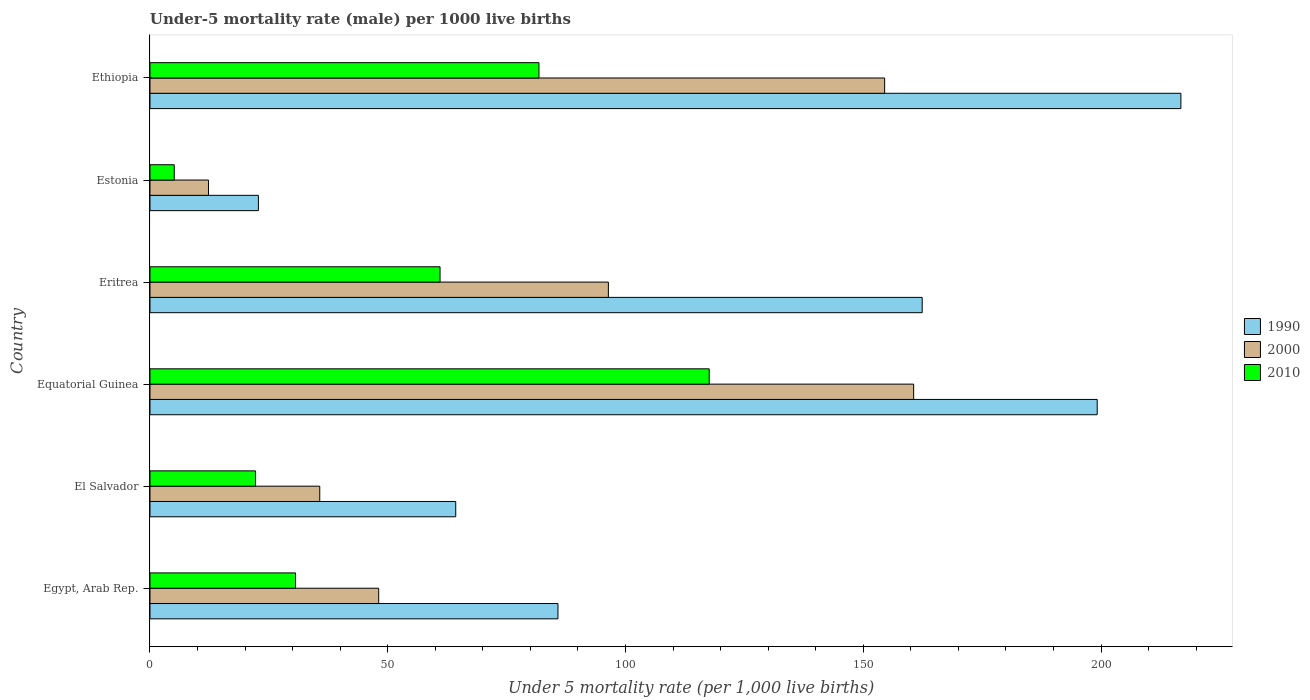How many different coloured bars are there?
Offer a terse response. 3. Are the number of bars per tick equal to the number of legend labels?
Provide a short and direct response. Yes. How many bars are there on the 6th tick from the bottom?
Offer a terse response. 3. What is the label of the 1st group of bars from the top?
Provide a succinct answer. Ethiopia. In how many cases, is the number of bars for a given country not equal to the number of legend labels?
Give a very brief answer. 0. What is the under-five mortality rate in 2000 in Eritrea?
Make the answer very short. 96.4. Across all countries, what is the maximum under-five mortality rate in 2000?
Your answer should be very brief. 160.6. Across all countries, what is the minimum under-five mortality rate in 2010?
Your response must be concise. 5.1. In which country was the under-five mortality rate in 2000 maximum?
Offer a terse response. Equatorial Guinea. In which country was the under-five mortality rate in 1990 minimum?
Ensure brevity in your answer.  Estonia. What is the total under-five mortality rate in 1990 in the graph?
Offer a terse response. 751.3. What is the difference between the under-five mortality rate in 2010 in Eritrea and that in Estonia?
Make the answer very short. 55.9. What is the difference between the under-five mortality rate in 1990 in Estonia and the under-five mortality rate in 2000 in Egypt, Arab Rep.?
Provide a short and direct response. -25.3. What is the average under-five mortality rate in 2010 per country?
Give a very brief answer. 53.05. What is the difference between the under-five mortality rate in 1990 and under-five mortality rate in 2010 in Estonia?
Provide a short and direct response. 17.7. What is the ratio of the under-five mortality rate in 1990 in Eritrea to that in Estonia?
Provide a short and direct response. 7.12. Is the under-five mortality rate in 2010 in El Salvador less than that in Ethiopia?
Offer a terse response. Yes. Is the difference between the under-five mortality rate in 1990 in Egypt, Arab Rep. and Estonia greater than the difference between the under-five mortality rate in 2010 in Egypt, Arab Rep. and Estonia?
Keep it short and to the point. Yes. What is the difference between the highest and the second highest under-five mortality rate in 2000?
Offer a very short reply. 6.1. What is the difference between the highest and the lowest under-five mortality rate in 2010?
Your response must be concise. 112.5. In how many countries, is the under-five mortality rate in 2010 greater than the average under-five mortality rate in 2010 taken over all countries?
Offer a very short reply. 3. Is the sum of the under-five mortality rate in 2010 in Eritrea and Estonia greater than the maximum under-five mortality rate in 1990 across all countries?
Provide a short and direct response. No. What does the 2nd bar from the top in Ethiopia represents?
Provide a succinct answer. 2000. Is it the case that in every country, the sum of the under-five mortality rate in 2000 and under-five mortality rate in 1990 is greater than the under-five mortality rate in 2010?
Keep it short and to the point. Yes. How many bars are there?
Ensure brevity in your answer.  18. What is the difference between two consecutive major ticks on the X-axis?
Your answer should be very brief. 50. Does the graph contain any zero values?
Provide a succinct answer. No. Where does the legend appear in the graph?
Give a very brief answer. Center right. How many legend labels are there?
Provide a short and direct response. 3. What is the title of the graph?
Keep it short and to the point. Under-5 mortality rate (male) per 1000 live births. What is the label or title of the X-axis?
Ensure brevity in your answer.  Under 5 mortality rate (per 1,0 live births). What is the label or title of the Y-axis?
Your answer should be very brief. Country. What is the Under 5 mortality rate (per 1,000 live births) of 1990 in Egypt, Arab Rep.?
Ensure brevity in your answer.  85.8. What is the Under 5 mortality rate (per 1,000 live births) of 2000 in Egypt, Arab Rep.?
Provide a succinct answer. 48.1. What is the Under 5 mortality rate (per 1,000 live births) of 2010 in Egypt, Arab Rep.?
Offer a very short reply. 30.6. What is the Under 5 mortality rate (per 1,000 live births) of 1990 in El Salvador?
Provide a short and direct response. 64.3. What is the Under 5 mortality rate (per 1,000 live births) of 2000 in El Salvador?
Provide a short and direct response. 35.7. What is the Under 5 mortality rate (per 1,000 live births) in 1990 in Equatorial Guinea?
Make the answer very short. 199.2. What is the Under 5 mortality rate (per 1,000 live births) of 2000 in Equatorial Guinea?
Provide a succinct answer. 160.6. What is the Under 5 mortality rate (per 1,000 live births) of 2010 in Equatorial Guinea?
Your answer should be very brief. 117.6. What is the Under 5 mortality rate (per 1,000 live births) of 1990 in Eritrea?
Your answer should be compact. 162.4. What is the Under 5 mortality rate (per 1,000 live births) in 2000 in Eritrea?
Provide a short and direct response. 96.4. What is the Under 5 mortality rate (per 1,000 live births) of 2010 in Eritrea?
Make the answer very short. 61. What is the Under 5 mortality rate (per 1,000 live births) in 1990 in Estonia?
Keep it short and to the point. 22.8. What is the Under 5 mortality rate (per 1,000 live births) of 1990 in Ethiopia?
Your answer should be very brief. 216.8. What is the Under 5 mortality rate (per 1,000 live births) in 2000 in Ethiopia?
Ensure brevity in your answer.  154.5. What is the Under 5 mortality rate (per 1,000 live births) in 2010 in Ethiopia?
Ensure brevity in your answer.  81.8. Across all countries, what is the maximum Under 5 mortality rate (per 1,000 live births) of 1990?
Offer a terse response. 216.8. Across all countries, what is the maximum Under 5 mortality rate (per 1,000 live births) of 2000?
Your answer should be compact. 160.6. Across all countries, what is the maximum Under 5 mortality rate (per 1,000 live births) in 2010?
Ensure brevity in your answer.  117.6. Across all countries, what is the minimum Under 5 mortality rate (per 1,000 live births) in 1990?
Offer a terse response. 22.8. What is the total Under 5 mortality rate (per 1,000 live births) of 1990 in the graph?
Ensure brevity in your answer.  751.3. What is the total Under 5 mortality rate (per 1,000 live births) in 2000 in the graph?
Offer a terse response. 507.6. What is the total Under 5 mortality rate (per 1,000 live births) of 2010 in the graph?
Your answer should be very brief. 318.3. What is the difference between the Under 5 mortality rate (per 1,000 live births) of 1990 in Egypt, Arab Rep. and that in El Salvador?
Ensure brevity in your answer.  21.5. What is the difference between the Under 5 mortality rate (per 1,000 live births) in 2000 in Egypt, Arab Rep. and that in El Salvador?
Provide a short and direct response. 12.4. What is the difference between the Under 5 mortality rate (per 1,000 live births) of 1990 in Egypt, Arab Rep. and that in Equatorial Guinea?
Provide a succinct answer. -113.4. What is the difference between the Under 5 mortality rate (per 1,000 live births) in 2000 in Egypt, Arab Rep. and that in Equatorial Guinea?
Give a very brief answer. -112.5. What is the difference between the Under 5 mortality rate (per 1,000 live births) of 2010 in Egypt, Arab Rep. and that in Equatorial Guinea?
Your answer should be very brief. -87. What is the difference between the Under 5 mortality rate (per 1,000 live births) of 1990 in Egypt, Arab Rep. and that in Eritrea?
Ensure brevity in your answer.  -76.6. What is the difference between the Under 5 mortality rate (per 1,000 live births) of 2000 in Egypt, Arab Rep. and that in Eritrea?
Give a very brief answer. -48.3. What is the difference between the Under 5 mortality rate (per 1,000 live births) of 2010 in Egypt, Arab Rep. and that in Eritrea?
Give a very brief answer. -30.4. What is the difference between the Under 5 mortality rate (per 1,000 live births) of 1990 in Egypt, Arab Rep. and that in Estonia?
Provide a short and direct response. 63. What is the difference between the Under 5 mortality rate (per 1,000 live births) in 2000 in Egypt, Arab Rep. and that in Estonia?
Ensure brevity in your answer.  35.8. What is the difference between the Under 5 mortality rate (per 1,000 live births) in 2010 in Egypt, Arab Rep. and that in Estonia?
Your response must be concise. 25.5. What is the difference between the Under 5 mortality rate (per 1,000 live births) of 1990 in Egypt, Arab Rep. and that in Ethiopia?
Your answer should be very brief. -131. What is the difference between the Under 5 mortality rate (per 1,000 live births) in 2000 in Egypt, Arab Rep. and that in Ethiopia?
Make the answer very short. -106.4. What is the difference between the Under 5 mortality rate (per 1,000 live births) of 2010 in Egypt, Arab Rep. and that in Ethiopia?
Keep it short and to the point. -51.2. What is the difference between the Under 5 mortality rate (per 1,000 live births) in 1990 in El Salvador and that in Equatorial Guinea?
Provide a succinct answer. -134.9. What is the difference between the Under 5 mortality rate (per 1,000 live births) in 2000 in El Salvador and that in Equatorial Guinea?
Provide a succinct answer. -124.9. What is the difference between the Under 5 mortality rate (per 1,000 live births) of 2010 in El Salvador and that in Equatorial Guinea?
Offer a very short reply. -95.4. What is the difference between the Under 5 mortality rate (per 1,000 live births) of 1990 in El Salvador and that in Eritrea?
Provide a short and direct response. -98.1. What is the difference between the Under 5 mortality rate (per 1,000 live births) of 2000 in El Salvador and that in Eritrea?
Your answer should be very brief. -60.7. What is the difference between the Under 5 mortality rate (per 1,000 live births) in 2010 in El Salvador and that in Eritrea?
Your answer should be compact. -38.8. What is the difference between the Under 5 mortality rate (per 1,000 live births) of 1990 in El Salvador and that in Estonia?
Offer a very short reply. 41.5. What is the difference between the Under 5 mortality rate (per 1,000 live births) of 2000 in El Salvador and that in Estonia?
Provide a succinct answer. 23.4. What is the difference between the Under 5 mortality rate (per 1,000 live births) in 2010 in El Salvador and that in Estonia?
Give a very brief answer. 17.1. What is the difference between the Under 5 mortality rate (per 1,000 live births) in 1990 in El Salvador and that in Ethiopia?
Offer a terse response. -152.5. What is the difference between the Under 5 mortality rate (per 1,000 live births) in 2000 in El Salvador and that in Ethiopia?
Offer a terse response. -118.8. What is the difference between the Under 5 mortality rate (per 1,000 live births) in 2010 in El Salvador and that in Ethiopia?
Make the answer very short. -59.6. What is the difference between the Under 5 mortality rate (per 1,000 live births) in 1990 in Equatorial Guinea and that in Eritrea?
Your answer should be compact. 36.8. What is the difference between the Under 5 mortality rate (per 1,000 live births) in 2000 in Equatorial Guinea and that in Eritrea?
Your answer should be very brief. 64.2. What is the difference between the Under 5 mortality rate (per 1,000 live births) in 2010 in Equatorial Guinea and that in Eritrea?
Your response must be concise. 56.6. What is the difference between the Under 5 mortality rate (per 1,000 live births) of 1990 in Equatorial Guinea and that in Estonia?
Offer a very short reply. 176.4. What is the difference between the Under 5 mortality rate (per 1,000 live births) of 2000 in Equatorial Guinea and that in Estonia?
Give a very brief answer. 148.3. What is the difference between the Under 5 mortality rate (per 1,000 live births) in 2010 in Equatorial Guinea and that in Estonia?
Your answer should be compact. 112.5. What is the difference between the Under 5 mortality rate (per 1,000 live births) in 1990 in Equatorial Guinea and that in Ethiopia?
Your response must be concise. -17.6. What is the difference between the Under 5 mortality rate (per 1,000 live births) in 2000 in Equatorial Guinea and that in Ethiopia?
Your response must be concise. 6.1. What is the difference between the Under 5 mortality rate (per 1,000 live births) in 2010 in Equatorial Guinea and that in Ethiopia?
Keep it short and to the point. 35.8. What is the difference between the Under 5 mortality rate (per 1,000 live births) in 1990 in Eritrea and that in Estonia?
Ensure brevity in your answer.  139.6. What is the difference between the Under 5 mortality rate (per 1,000 live births) of 2000 in Eritrea and that in Estonia?
Your answer should be compact. 84.1. What is the difference between the Under 5 mortality rate (per 1,000 live births) of 2010 in Eritrea and that in Estonia?
Provide a short and direct response. 55.9. What is the difference between the Under 5 mortality rate (per 1,000 live births) of 1990 in Eritrea and that in Ethiopia?
Your answer should be compact. -54.4. What is the difference between the Under 5 mortality rate (per 1,000 live births) of 2000 in Eritrea and that in Ethiopia?
Offer a terse response. -58.1. What is the difference between the Under 5 mortality rate (per 1,000 live births) of 2010 in Eritrea and that in Ethiopia?
Offer a very short reply. -20.8. What is the difference between the Under 5 mortality rate (per 1,000 live births) of 1990 in Estonia and that in Ethiopia?
Offer a very short reply. -194. What is the difference between the Under 5 mortality rate (per 1,000 live births) of 2000 in Estonia and that in Ethiopia?
Provide a short and direct response. -142.2. What is the difference between the Under 5 mortality rate (per 1,000 live births) of 2010 in Estonia and that in Ethiopia?
Ensure brevity in your answer.  -76.7. What is the difference between the Under 5 mortality rate (per 1,000 live births) of 1990 in Egypt, Arab Rep. and the Under 5 mortality rate (per 1,000 live births) of 2000 in El Salvador?
Provide a succinct answer. 50.1. What is the difference between the Under 5 mortality rate (per 1,000 live births) in 1990 in Egypt, Arab Rep. and the Under 5 mortality rate (per 1,000 live births) in 2010 in El Salvador?
Keep it short and to the point. 63.6. What is the difference between the Under 5 mortality rate (per 1,000 live births) of 2000 in Egypt, Arab Rep. and the Under 5 mortality rate (per 1,000 live births) of 2010 in El Salvador?
Provide a short and direct response. 25.9. What is the difference between the Under 5 mortality rate (per 1,000 live births) of 1990 in Egypt, Arab Rep. and the Under 5 mortality rate (per 1,000 live births) of 2000 in Equatorial Guinea?
Make the answer very short. -74.8. What is the difference between the Under 5 mortality rate (per 1,000 live births) of 1990 in Egypt, Arab Rep. and the Under 5 mortality rate (per 1,000 live births) of 2010 in Equatorial Guinea?
Your answer should be very brief. -31.8. What is the difference between the Under 5 mortality rate (per 1,000 live births) of 2000 in Egypt, Arab Rep. and the Under 5 mortality rate (per 1,000 live births) of 2010 in Equatorial Guinea?
Keep it short and to the point. -69.5. What is the difference between the Under 5 mortality rate (per 1,000 live births) in 1990 in Egypt, Arab Rep. and the Under 5 mortality rate (per 1,000 live births) in 2010 in Eritrea?
Your answer should be very brief. 24.8. What is the difference between the Under 5 mortality rate (per 1,000 live births) in 1990 in Egypt, Arab Rep. and the Under 5 mortality rate (per 1,000 live births) in 2000 in Estonia?
Provide a short and direct response. 73.5. What is the difference between the Under 5 mortality rate (per 1,000 live births) of 1990 in Egypt, Arab Rep. and the Under 5 mortality rate (per 1,000 live births) of 2010 in Estonia?
Give a very brief answer. 80.7. What is the difference between the Under 5 mortality rate (per 1,000 live births) in 1990 in Egypt, Arab Rep. and the Under 5 mortality rate (per 1,000 live births) in 2000 in Ethiopia?
Offer a very short reply. -68.7. What is the difference between the Under 5 mortality rate (per 1,000 live births) of 1990 in Egypt, Arab Rep. and the Under 5 mortality rate (per 1,000 live births) of 2010 in Ethiopia?
Offer a very short reply. 4. What is the difference between the Under 5 mortality rate (per 1,000 live births) of 2000 in Egypt, Arab Rep. and the Under 5 mortality rate (per 1,000 live births) of 2010 in Ethiopia?
Your answer should be compact. -33.7. What is the difference between the Under 5 mortality rate (per 1,000 live births) of 1990 in El Salvador and the Under 5 mortality rate (per 1,000 live births) of 2000 in Equatorial Guinea?
Make the answer very short. -96.3. What is the difference between the Under 5 mortality rate (per 1,000 live births) in 1990 in El Salvador and the Under 5 mortality rate (per 1,000 live births) in 2010 in Equatorial Guinea?
Make the answer very short. -53.3. What is the difference between the Under 5 mortality rate (per 1,000 live births) in 2000 in El Salvador and the Under 5 mortality rate (per 1,000 live births) in 2010 in Equatorial Guinea?
Provide a succinct answer. -81.9. What is the difference between the Under 5 mortality rate (per 1,000 live births) of 1990 in El Salvador and the Under 5 mortality rate (per 1,000 live births) of 2000 in Eritrea?
Your answer should be very brief. -32.1. What is the difference between the Under 5 mortality rate (per 1,000 live births) in 1990 in El Salvador and the Under 5 mortality rate (per 1,000 live births) in 2010 in Eritrea?
Offer a very short reply. 3.3. What is the difference between the Under 5 mortality rate (per 1,000 live births) in 2000 in El Salvador and the Under 5 mortality rate (per 1,000 live births) in 2010 in Eritrea?
Your response must be concise. -25.3. What is the difference between the Under 5 mortality rate (per 1,000 live births) of 1990 in El Salvador and the Under 5 mortality rate (per 1,000 live births) of 2010 in Estonia?
Provide a short and direct response. 59.2. What is the difference between the Under 5 mortality rate (per 1,000 live births) in 2000 in El Salvador and the Under 5 mortality rate (per 1,000 live births) in 2010 in Estonia?
Provide a succinct answer. 30.6. What is the difference between the Under 5 mortality rate (per 1,000 live births) of 1990 in El Salvador and the Under 5 mortality rate (per 1,000 live births) of 2000 in Ethiopia?
Keep it short and to the point. -90.2. What is the difference between the Under 5 mortality rate (per 1,000 live births) of 1990 in El Salvador and the Under 5 mortality rate (per 1,000 live births) of 2010 in Ethiopia?
Make the answer very short. -17.5. What is the difference between the Under 5 mortality rate (per 1,000 live births) in 2000 in El Salvador and the Under 5 mortality rate (per 1,000 live births) in 2010 in Ethiopia?
Your response must be concise. -46.1. What is the difference between the Under 5 mortality rate (per 1,000 live births) in 1990 in Equatorial Guinea and the Under 5 mortality rate (per 1,000 live births) in 2000 in Eritrea?
Give a very brief answer. 102.8. What is the difference between the Under 5 mortality rate (per 1,000 live births) of 1990 in Equatorial Guinea and the Under 5 mortality rate (per 1,000 live births) of 2010 in Eritrea?
Your response must be concise. 138.2. What is the difference between the Under 5 mortality rate (per 1,000 live births) in 2000 in Equatorial Guinea and the Under 5 mortality rate (per 1,000 live births) in 2010 in Eritrea?
Provide a succinct answer. 99.6. What is the difference between the Under 5 mortality rate (per 1,000 live births) of 1990 in Equatorial Guinea and the Under 5 mortality rate (per 1,000 live births) of 2000 in Estonia?
Ensure brevity in your answer.  186.9. What is the difference between the Under 5 mortality rate (per 1,000 live births) in 1990 in Equatorial Guinea and the Under 5 mortality rate (per 1,000 live births) in 2010 in Estonia?
Provide a succinct answer. 194.1. What is the difference between the Under 5 mortality rate (per 1,000 live births) of 2000 in Equatorial Guinea and the Under 5 mortality rate (per 1,000 live births) of 2010 in Estonia?
Give a very brief answer. 155.5. What is the difference between the Under 5 mortality rate (per 1,000 live births) of 1990 in Equatorial Guinea and the Under 5 mortality rate (per 1,000 live births) of 2000 in Ethiopia?
Offer a very short reply. 44.7. What is the difference between the Under 5 mortality rate (per 1,000 live births) of 1990 in Equatorial Guinea and the Under 5 mortality rate (per 1,000 live births) of 2010 in Ethiopia?
Your answer should be compact. 117.4. What is the difference between the Under 5 mortality rate (per 1,000 live births) in 2000 in Equatorial Guinea and the Under 5 mortality rate (per 1,000 live births) in 2010 in Ethiopia?
Make the answer very short. 78.8. What is the difference between the Under 5 mortality rate (per 1,000 live births) of 1990 in Eritrea and the Under 5 mortality rate (per 1,000 live births) of 2000 in Estonia?
Your response must be concise. 150.1. What is the difference between the Under 5 mortality rate (per 1,000 live births) of 1990 in Eritrea and the Under 5 mortality rate (per 1,000 live births) of 2010 in Estonia?
Provide a short and direct response. 157.3. What is the difference between the Under 5 mortality rate (per 1,000 live births) in 2000 in Eritrea and the Under 5 mortality rate (per 1,000 live births) in 2010 in Estonia?
Your answer should be compact. 91.3. What is the difference between the Under 5 mortality rate (per 1,000 live births) of 1990 in Eritrea and the Under 5 mortality rate (per 1,000 live births) of 2010 in Ethiopia?
Provide a succinct answer. 80.6. What is the difference between the Under 5 mortality rate (per 1,000 live births) in 1990 in Estonia and the Under 5 mortality rate (per 1,000 live births) in 2000 in Ethiopia?
Your response must be concise. -131.7. What is the difference between the Under 5 mortality rate (per 1,000 live births) of 1990 in Estonia and the Under 5 mortality rate (per 1,000 live births) of 2010 in Ethiopia?
Provide a succinct answer. -59. What is the difference between the Under 5 mortality rate (per 1,000 live births) in 2000 in Estonia and the Under 5 mortality rate (per 1,000 live births) in 2010 in Ethiopia?
Make the answer very short. -69.5. What is the average Under 5 mortality rate (per 1,000 live births) in 1990 per country?
Your answer should be very brief. 125.22. What is the average Under 5 mortality rate (per 1,000 live births) of 2000 per country?
Your answer should be compact. 84.6. What is the average Under 5 mortality rate (per 1,000 live births) in 2010 per country?
Provide a succinct answer. 53.05. What is the difference between the Under 5 mortality rate (per 1,000 live births) of 1990 and Under 5 mortality rate (per 1,000 live births) of 2000 in Egypt, Arab Rep.?
Make the answer very short. 37.7. What is the difference between the Under 5 mortality rate (per 1,000 live births) of 1990 and Under 5 mortality rate (per 1,000 live births) of 2010 in Egypt, Arab Rep.?
Make the answer very short. 55.2. What is the difference between the Under 5 mortality rate (per 1,000 live births) of 2000 and Under 5 mortality rate (per 1,000 live births) of 2010 in Egypt, Arab Rep.?
Ensure brevity in your answer.  17.5. What is the difference between the Under 5 mortality rate (per 1,000 live births) of 1990 and Under 5 mortality rate (per 1,000 live births) of 2000 in El Salvador?
Your answer should be compact. 28.6. What is the difference between the Under 5 mortality rate (per 1,000 live births) of 1990 and Under 5 mortality rate (per 1,000 live births) of 2010 in El Salvador?
Give a very brief answer. 42.1. What is the difference between the Under 5 mortality rate (per 1,000 live births) in 1990 and Under 5 mortality rate (per 1,000 live births) in 2000 in Equatorial Guinea?
Give a very brief answer. 38.6. What is the difference between the Under 5 mortality rate (per 1,000 live births) in 1990 and Under 5 mortality rate (per 1,000 live births) in 2010 in Equatorial Guinea?
Give a very brief answer. 81.6. What is the difference between the Under 5 mortality rate (per 1,000 live births) of 1990 and Under 5 mortality rate (per 1,000 live births) of 2000 in Eritrea?
Make the answer very short. 66. What is the difference between the Under 5 mortality rate (per 1,000 live births) in 1990 and Under 5 mortality rate (per 1,000 live births) in 2010 in Eritrea?
Give a very brief answer. 101.4. What is the difference between the Under 5 mortality rate (per 1,000 live births) in 2000 and Under 5 mortality rate (per 1,000 live births) in 2010 in Eritrea?
Your answer should be very brief. 35.4. What is the difference between the Under 5 mortality rate (per 1,000 live births) of 2000 and Under 5 mortality rate (per 1,000 live births) of 2010 in Estonia?
Make the answer very short. 7.2. What is the difference between the Under 5 mortality rate (per 1,000 live births) in 1990 and Under 5 mortality rate (per 1,000 live births) in 2000 in Ethiopia?
Keep it short and to the point. 62.3. What is the difference between the Under 5 mortality rate (per 1,000 live births) of 1990 and Under 5 mortality rate (per 1,000 live births) of 2010 in Ethiopia?
Make the answer very short. 135. What is the difference between the Under 5 mortality rate (per 1,000 live births) of 2000 and Under 5 mortality rate (per 1,000 live births) of 2010 in Ethiopia?
Provide a short and direct response. 72.7. What is the ratio of the Under 5 mortality rate (per 1,000 live births) of 1990 in Egypt, Arab Rep. to that in El Salvador?
Ensure brevity in your answer.  1.33. What is the ratio of the Under 5 mortality rate (per 1,000 live births) in 2000 in Egypt, Arab Rep. to that in El Salvador?
Your answer should be compact. 1.35. What is the ratio of the Under 5 mortality rate (per 1,000 live births) in 2010 in Egypt, Arab Rep. to that in El Salvador?
Your answer should be very brief. 1.38. What is the ratio of the Under 5 mortality rate (per 1,000 live births) in 1990 in Egypt, Arab Rep. to that in Equatorial Guinea?
Provide a succinct answer. 0.43. What is the ratio of the Under 5 mortality rate (per 1,000 live births) in 2000 in Egypt, Arab Rep. to that in Equatorial Guinea?
Provide a short and direct response. 0.3. What is the ratio of the Under 5 mortality rate (per 1,000 live births) of 2010 in Egypt, Arab Rep. to that in Equatorial Guinea?
Your answer should be compact. 0.26. What is the ratio of the Under 5 mortality rate (per 1,000 live births) of 1990 in Egypt, Arab Rep. to that in Eritrea?
Your answer should be very brief. 0.53. What is the ratio of the Under 5 mortality rate (per 1,000 live births) of 2000 in Egypt, Arab Rep. to that in Eritrea?
Offer a very short reply. 0.5. What is the ratio of the Under 5 mortality rate (per 1,000 live births) in 2010 in Egypt, Arab Rep. to that in Eritrea?
Your response must be concise. 0.5. What is the ratio of the Under 5 mortality rate (per 1,000 live births) in 1990 in Egypt, Arab Rep. to that in Estonia?
Ensure brevity in your answer.  3.76. What is the ratio of the Under 5 mortality rate (per 1,000 live births) in 2000 in Egypt, Arab Rep. to that in Estonia?
Your response must be concise. 3.91. What is the ratio of the Under 5 mortality rate (per 1,000 live births) of 1990 in Egypt, Arab Rep. to that in Ethiopia?
Your answer should be very brief. 0.4. What is the ratio of the Under 5 mortality rate (per 1,000 live births) of 2000 in Egypt, Arab Rep. to that in Ethiopia?
Your answer should be very brief. 0.31. What is the ratio of the Under 5 mortality rate (per 1,000 live births) in 2010 in Egypt, Arab Rep. to that in Ethiopia?
Your answer should be compact. 0.37. What is the ratio of the Under 5 mortality rate (per 1,000 live births) in 1990 in El Salvador to that in Equatorial Guinea?
Offer a very short reply. 0.32. What is the ratio of the Under 5 mortality rate (per 1,000 live births) in 2000 in El Salvador to that in Equatorial Guinea?
Your answer should be very brief. 0.22. What is the ratio of the Under 5 mortality rate (per 1,000 live births) of 2010 in El Salvador to that in Equatorial Guinea?
Your response must be concise. 0.19. What is the ratio of the Under 5 mortality rate (per 1,000 live births) of 1990 in El Salvador to that in Eritrea?
Offer a very short reply. 0.4. What is the ratio of the Under 5 mortality rate (per 1,000 live births) of 2000 in El Salvador to that in Eritrea?
Provide a short and direct response. 0.37. What is the ratio of the Under 5 mortality rate (per 1,000 live births) in 2010 in El Salvador to that in Eritrea?
Your answer should be compact. 0.36. What is the ratio of the Under 5 mortality rate (per 1,000 live births) of 1990 in El Salvador to that in Estonia?
Keep it short and to the point. 2.82. What is the ratio of the Under 5 mortality rate (per 1,000 live births) in 2000 in El Salvador to that in Estonia?
Keep it short and to the point. 2.9. What is the ratio of the Under 5 mortality rate (per 1,000 live births) in 2010 in El Salvador to that in Estonia?
Your response must be concise. 4.35. What is the ratio of the Under 5 mortality rate (per 1,000 live births) in 1990 in El Salvador to that in Ethiopia?
Offer a very short reply. 0.3. What is the ratio of the Under 5 mortality rate (per 1,000 live births) of 2000 in El Salvador to that in Ethiopia?
Provide a succinct answer. 0.23. What is the ratio of the Under 5 mortality rate (per 1,000 live births) in 2010 in El Salvador to that in Ethiopia?
Provide a succinct answer. 0.27. What is the ratio of the Under 5 mortality rate (per 1,000 live births) in 1990 in Equatorial Guinea to that in Eritrea?
Offer a very short reply. 1.23. What is the ratio of the Under 5 mortality rate (per 1,000 live births) of 2000 in Equatorial Guinea to that in Eritrea?
Give a very brief answer. 1.67. What is the ratio of the Under 5 mortality rate (per 1,000 live births) in 2010 in Equatorial Guinea to that in Eritrea?
Your answer should be very brief. 1.93. What is the ratio of the Under 5 mortality rate (per 1,000 live births) of 1990 in Equatorial Guinea to that in Estonia?
Ensure brevity in your answer.  8.74. What is the ratio of the Under 5 mortality rate (per 1,000 live births) in 2000 in Equatorial Guinea to that in Estonia?
Provide a short and direct response. 13.06. What is the ratio of the Under 5 mortality rate (per 1,000 live births) of 2010 in Equatorial Guinea to that in Estonia?
Your answer should be compact. 23.06. What is the ratio of the Under 5 mortality rate (per 1,000 live births) of 1990 in Equatorial Guinea to that in Ethiopia?
Provide a short and direct response. 0.92. What is the ratio of the Under 5 mortality rate (per 1,000 live births) of 2000 in Equatorial Guinea to that in Ethiopia?
Your answer should be compact. 1.04. What is the ratio of the Under 5 mortality rate (per 1,000 live births) in 2010 in Equatorial Guinea to that in Ethiopia?
Provide a short and direct response. 1.44. What is the ratio of the Under 5 mortality rate (per 1,000 live births) of 1990 in Eritrea to that in Estonia?
Your answer should be compact. 7.12. What is the ratio of the Under 5 mortality rate (per 1,000 live births) in 2000 in Eritrea to that in Estonia?
Offer a terse response. 7.84. What is the ratio of the Under 5 mortality rate (per 1,000 live births) of 2010 in Eritrea to that in Estonia?
Give a very brief answer. 11.96. What is the ratio of the Under 5 mortality rate (per 1,000 live births) in 1990 in Eritrea to that in Ethiopia?
Ensure brevity in your answer.  0.75. What is the ratio of the Under 5 mortality rate (per 1,000 live births) of 2000 in Eritrea to that in Ethiopia?
Offer a terse response. 0.62. What is the ratio of the Under 5 mortality rate (per 1,000 live births) of 2010 in Eritrea to that in Ethiopia?
Provide a succinct answer. 0.75. What is the ratio of the Under 5 mortality rate (per 1,000 live births) in 1990 in Estonia to that in Ethiopia?
Ensure brevity in your answer.  0.11. What is the ratio of the Under 5 mortality rate (per 1,000 live births) of 2000 in Estonia to that in Ethiopia?
Provide a succinct answer. 0.08. What is the ratio of the Under 5 mortality rate (per 1,000 live births) of 2010 in Estonia to that in Ethiopia?
Ensure brevity in your answer.  0.06. What is the difference between the highest and the second highest Under 5 mortality rate (per 1,000 live births) in 2010?
Keep it short and to the point. 35.8. What is the difference between the highest and the lowest Under 5 mortality rate (per 1,000 live births) in 1990?
Give a very brief answer. 194. What is the difference between the highest and the lowest Under 5 mortality rate (per 1,000 live births) of 2000?
Offer a terse response. 148.3. What is the difference between the highest and the lowest Under 5 mortality rate (per 1,000 live births) of 2010?
Keep it short and to the point. 112.5. 